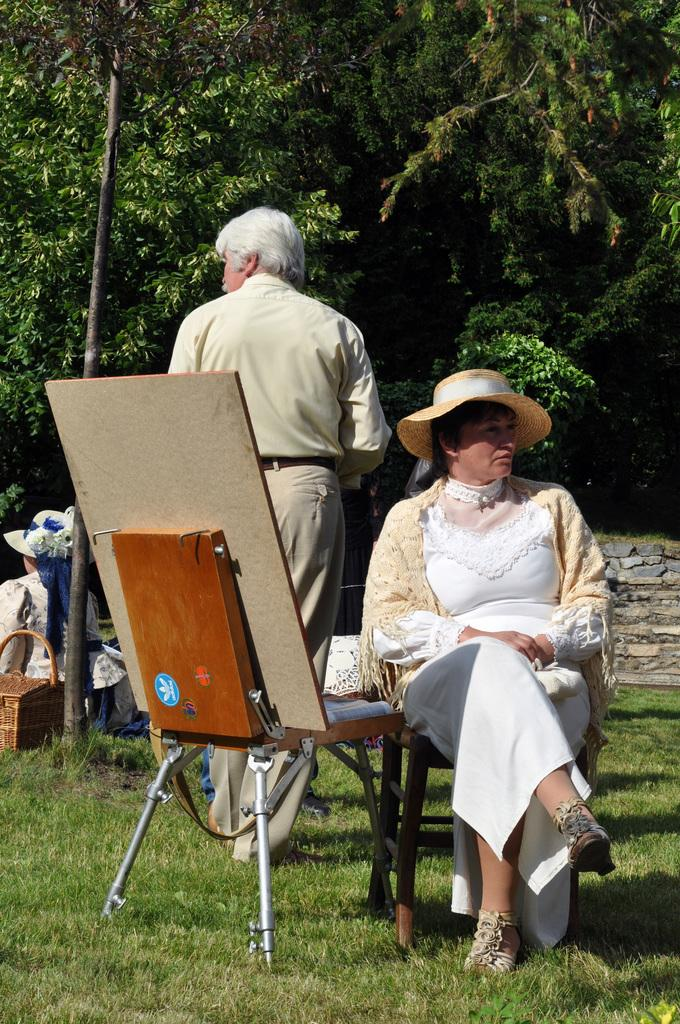What is the woman in the image doing? The woman is sitting on a chair in the image. Who is present behind the woman? There is a man standing behind the woman in the image. Can you describe the position of the other woman in the image? There is another woman sitting at a pole in the image. What can be seen in the background of the image? Trees are visible in the background of the image. What type of hole can be seen in the image? There is no hole present in the image. Is there a road visible in the image? No, there is no road visible in the image. 